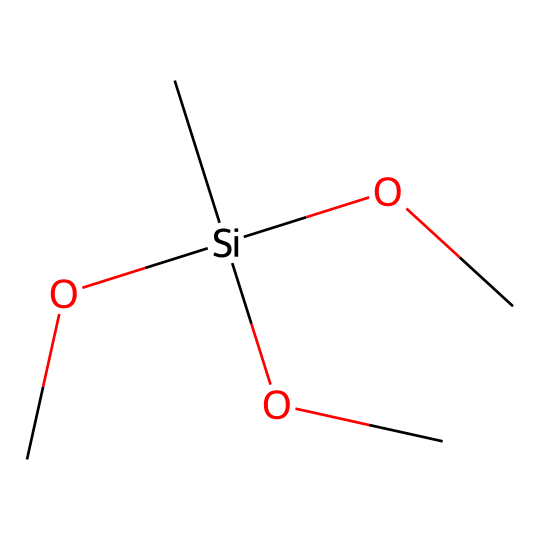What is the name of this chemical? The SMILES representation corresponds to methyltrimethoxysilane, where the "C" represents the methyl group and the "Si" is the silicon atom with three methoxy groups attached.
Answer: methyltrimethoxysilane How many oxygen atoms are present in the molecule? The SMILES shows three "OC" segments, indicating there are three methoxy groups, each containing one oxygen atom. Therefore, there are three oxygen atoms.
Answer: 3 What is the central atom in this chemical structure? The central atom is silicon (Si), which is connected to the three methoxy groups and the methyl group.
Answer: silicon What type of chemical bonds are present in methyltrimethoxysilane? The chemical features covalent bonds between the silicon atom and the surrounding atoms: the methyl group and the three methoxy groups, reflecting the typical bonding in silanes.
Answer: covalent Why is methyltrimethoxysilane used in water-repellent treatments? Its silane structure allows for strong bonding to inorganic surfaces, which creates a hydrophobic layer, effectively repelling water when applied to electronic components.
Answer: hydrophobic layer How many carbon atoms are in this molecule? The SMILES indicates one "C" for the methyl group and three "C" from the three methoxy groups, giving a total of four carbon atoms.
Answer: 4 